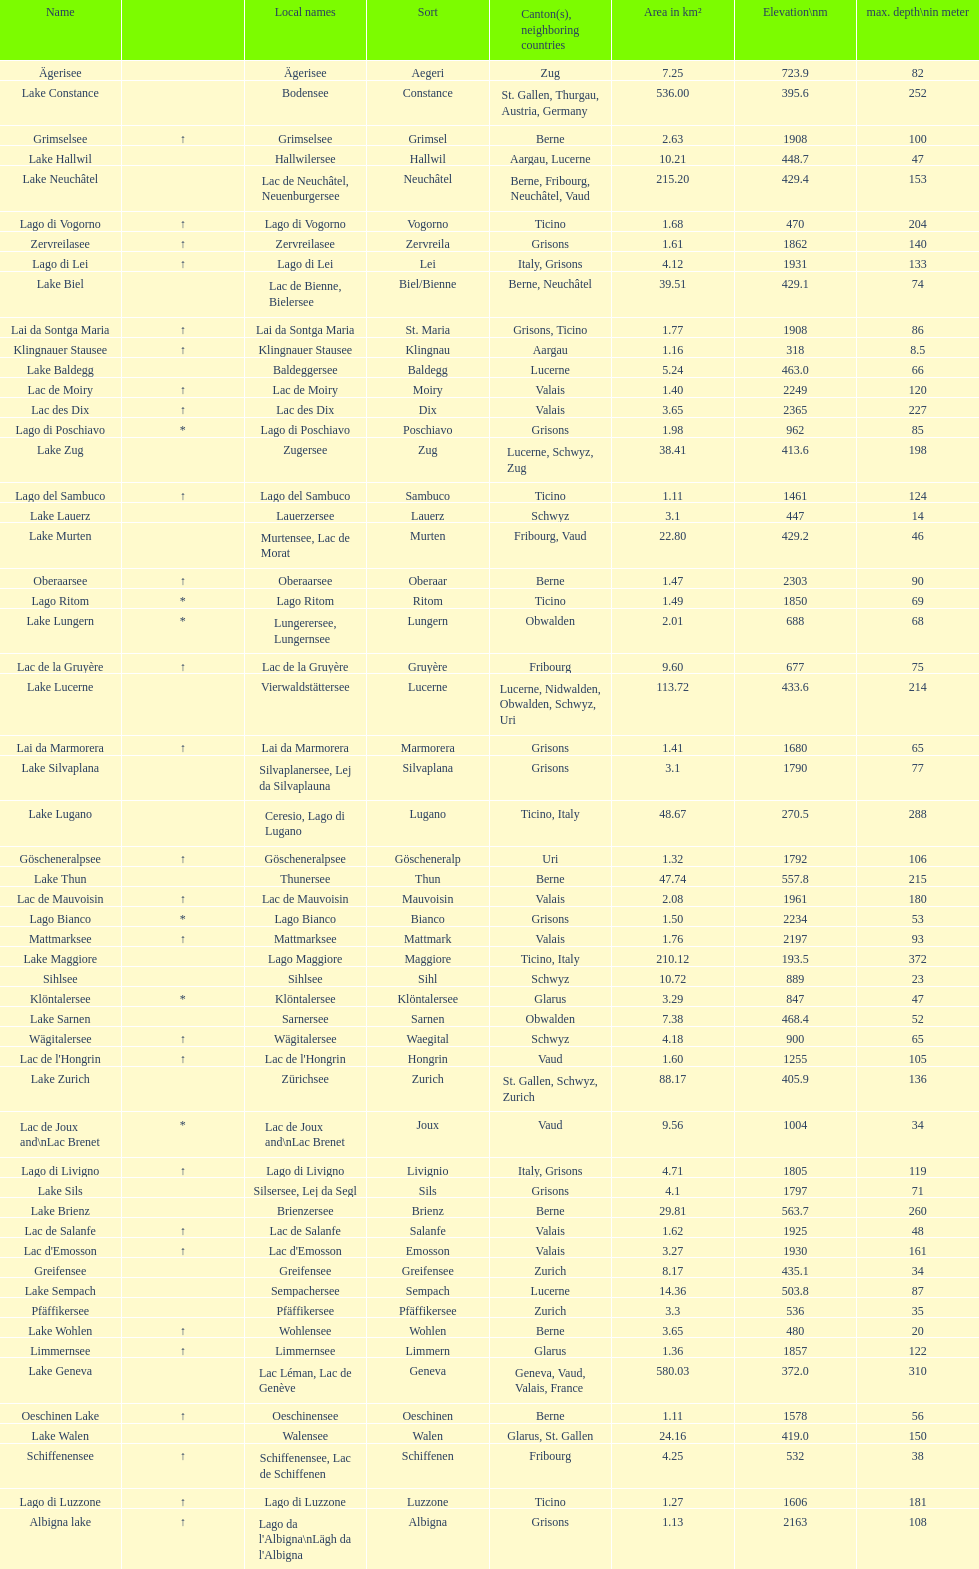Which lake occupies a smaller area in km²? albigna lake or oeschinen lake? Oeschinen Lake. 